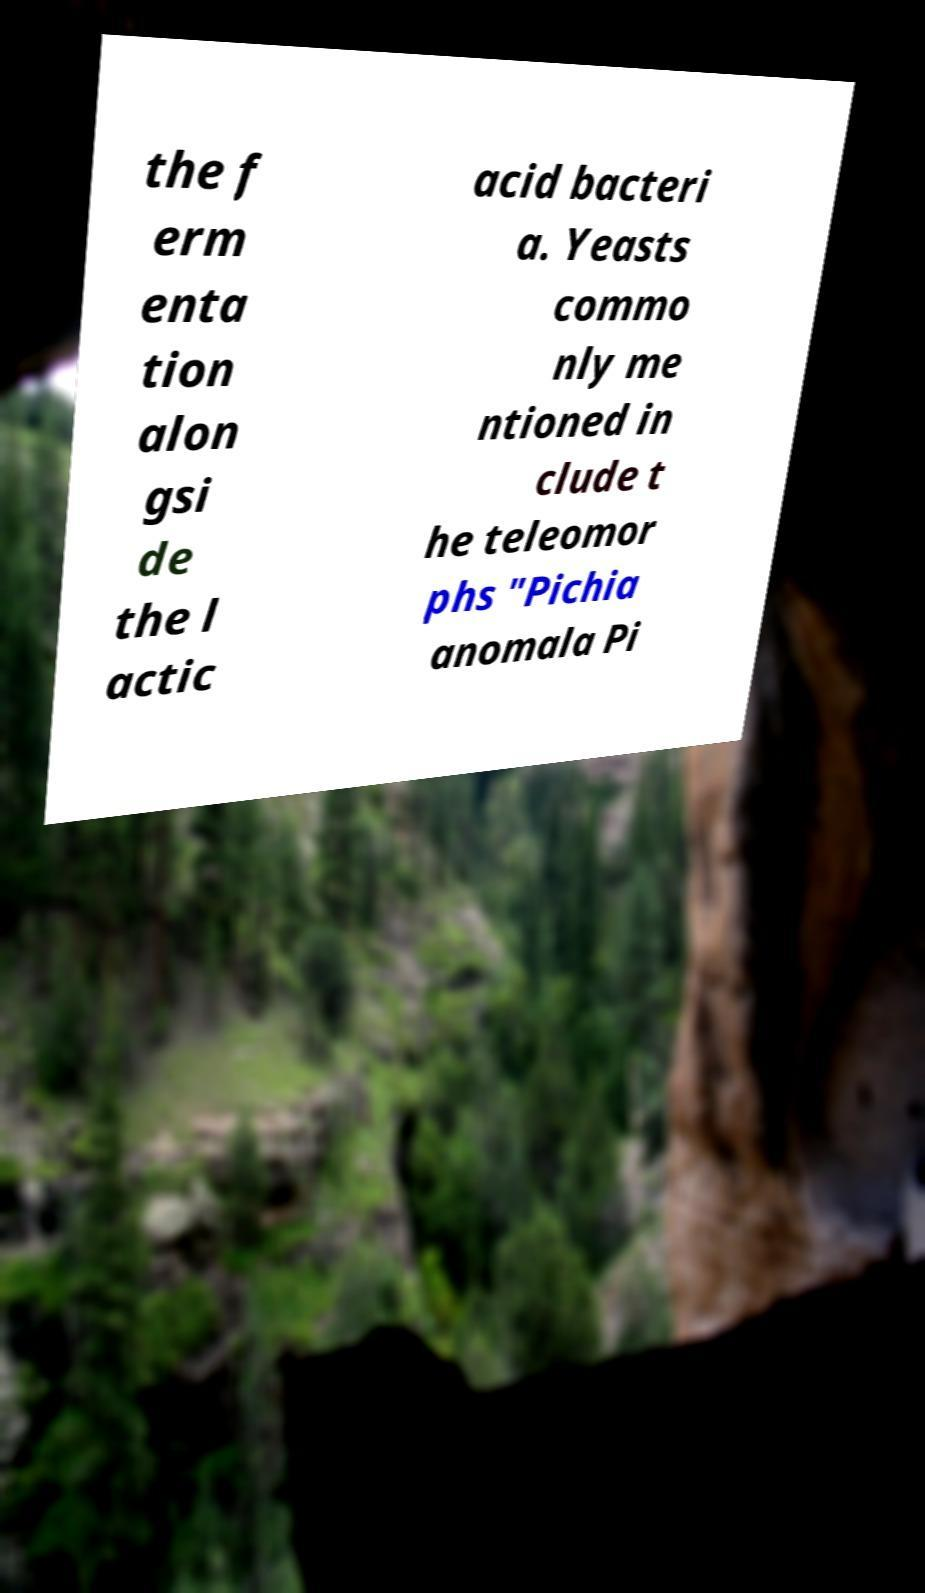Can you read and provide the text displayed in the image?This photo seems to have some interesting text. Can you extract and type it out for me? the f erm enta tion alon gsi de the l actic acid bacteri a. Yeasts commo nly me ntioned in clude t he teleomor phs "Pichia anomala Pi 